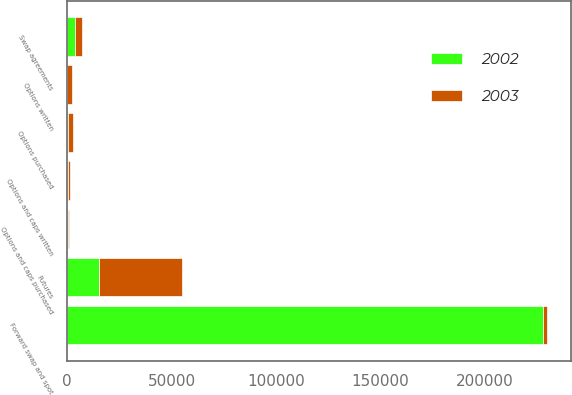Convert chart. <chart><loc_0><loc_0><loc_500><loc_500><stacked_bar_chart><ecel><fcel>Swap agreements<fcel>Options and caps purchased<fcel>Options and caps written<fcel>Futures<fcel>Forward swap and spot<fcel>Options purchased<fcel>Options written<nl><fcel>2003<fcel>3154<fcel>332<fcel>656<fcel>40003<fcel>2064<fcel>2243<fcel>2064<nl><fcel>2002<fcel>3847<fcel>351<fcel>483<fcel>15078<fcel>227782<fcel>350<fcel>136<nl></chart> 